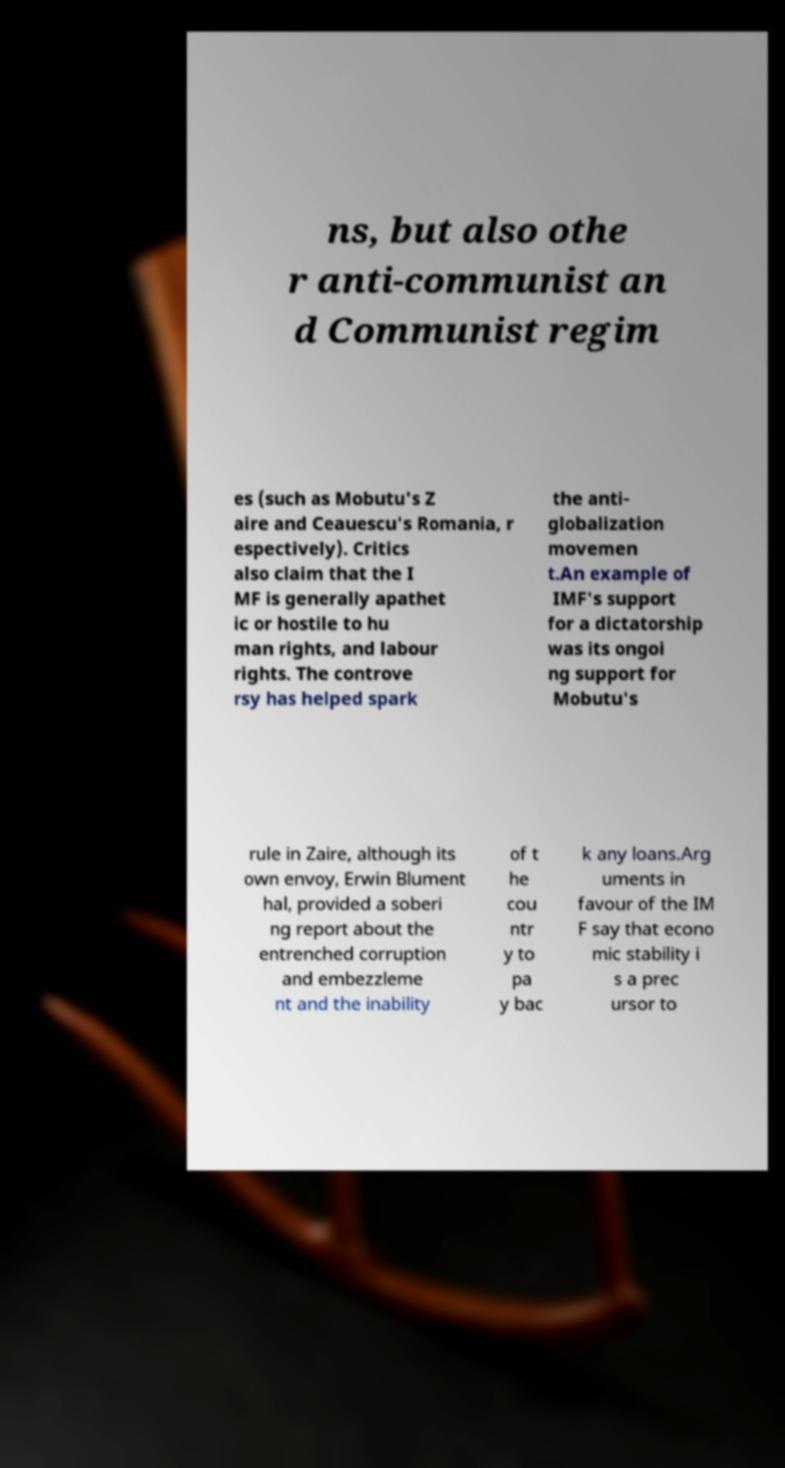I need the written content from this picture converted into text. Can you do that? ns, but also othe r anti-communist an d Communist regim es (such as Mobutu's Z aire and Ceauescu's Romania, r espectively). Critics also claim that the I MF is generally apathet ic or hostile to hu man rights, and labour rights. The controve rsy has helped spark the anti- globalization movemen t.An example of IMF's support for a dictatorship was its ongoi ng support for Mobutu's rule in Zaire, although its own envoy, Erwin Blument hal, provided a soberi ng report about the entrenched corruption and embezzleme nt and the inability of t he cou ntr y to pa y bac k any loans.Arg uments in favour of the IM F say that econo mic stability i s a prec ursor to 